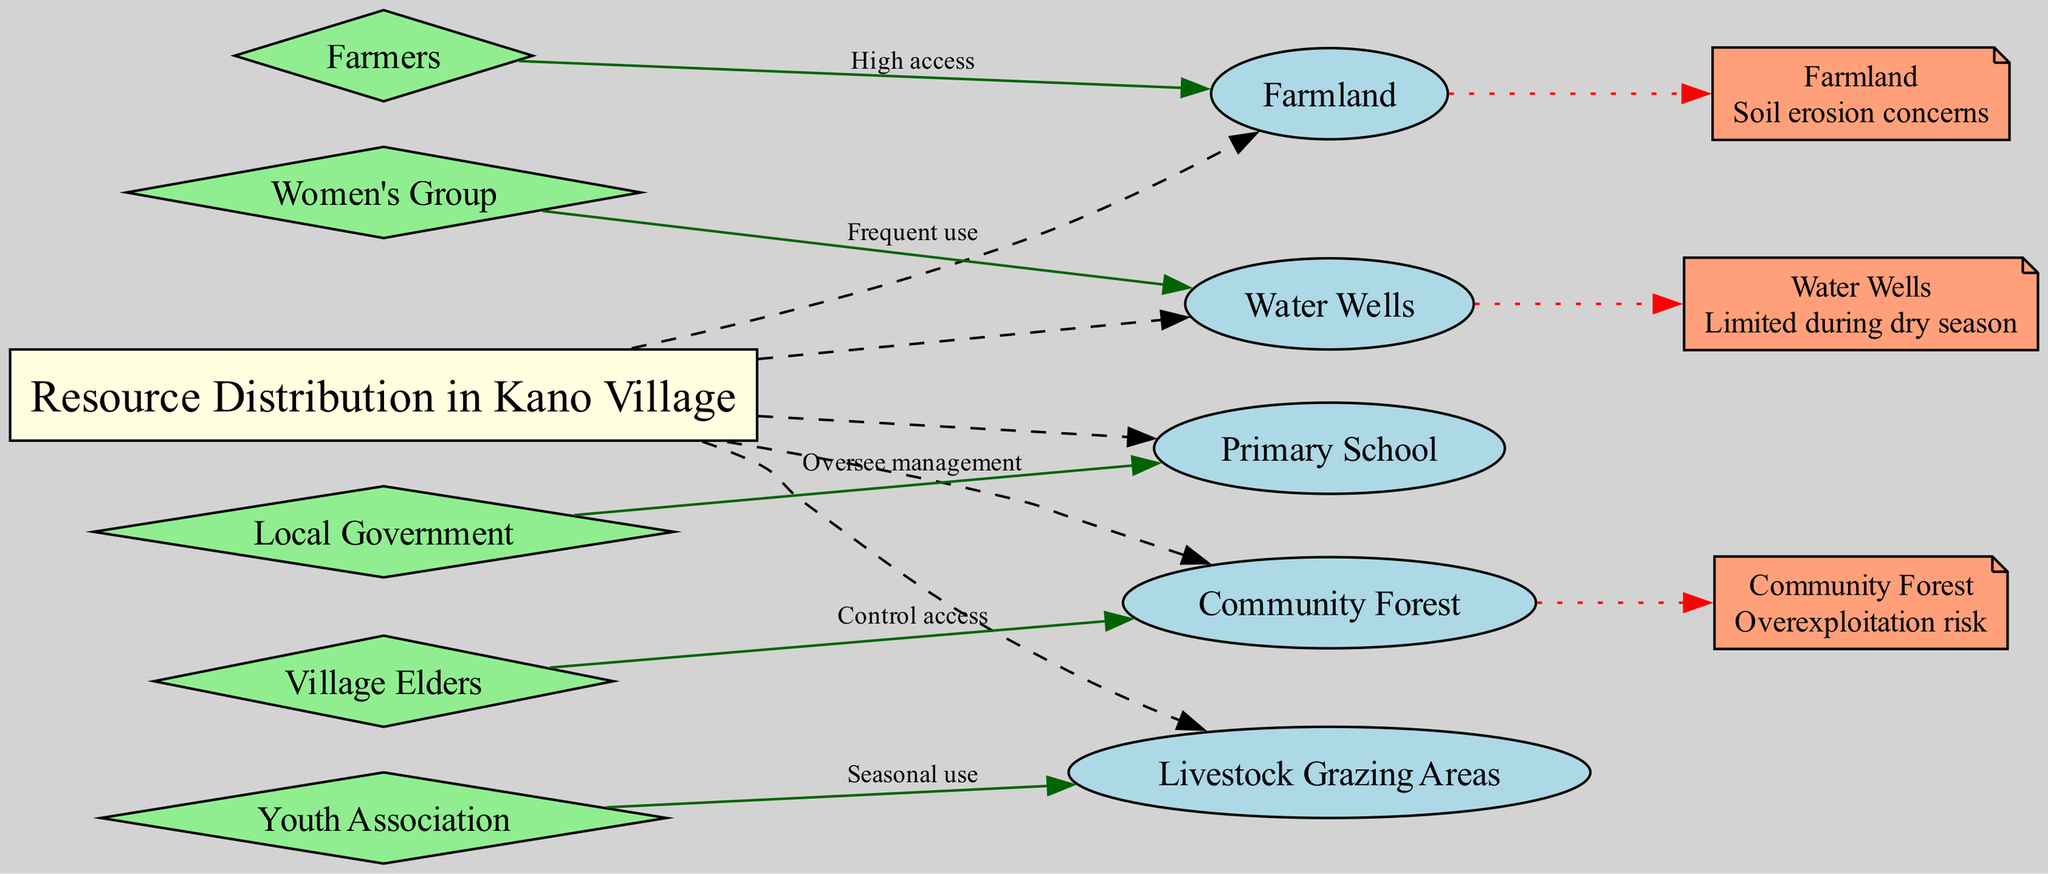What is the central topic of the diagram? The central topic is explicitly stated in the diagram as "Resource Distribution in Kano Village."
Answer: Resource Distribution in Kano Village How many resource nodes are there in the diagram? The diagram lists 5 resource nodes: Water Wells, Farmland, Community Forest, Livestock Grazing Areas, and Primary School. Counting these gives a total of 5.
Answer: 5 Which stakeholder group has "High access" to Farmland? The access pattern indicates that Farmers have "High access" to Farmland. This is directly stated in the access patterns section of the diagram.
Answer: Farmers What type of access do Women's Groups have to Water Wells? The access pattern states that Women's Groups have "Frequent use" of Water Wells, which is clearly indicated in the diagram.
Answer: Frequent use What constraint is associated with Water Wells? The diagram states that Water Wells have a constraint of "Limited during dry season." This is directly mentioned in the constraints section.
Answer: Limited during dry season Which stakeholder is responsible for overseeing the management of the Primary School? According to the access pattern, the Local Government is responsible for overseeing the management of the Primary School, as explicitly shown in the diagram.
Answer: Local Government What is the issue related to Community Forest? The diagram highlights that the Community Forest has a risk of "Overexploitation," which is stated in the constraints section.
Answer: Overexploitation risk Which stakeholder uses Livestock Grazing Areas seasonally? The Youth Association is identified to have "Seasonal use" of Livestock Grazing Areas according to the access patterns presented in the diagram.
Answer: Youth Association How many stakeholders are represented in the diagram? The diagram presents 5 stakeholder groups: Farmers, Women's Group, Village Elders, Youth Association, and Local Government, making the total count of stakeholders 5.
Answer: 5 